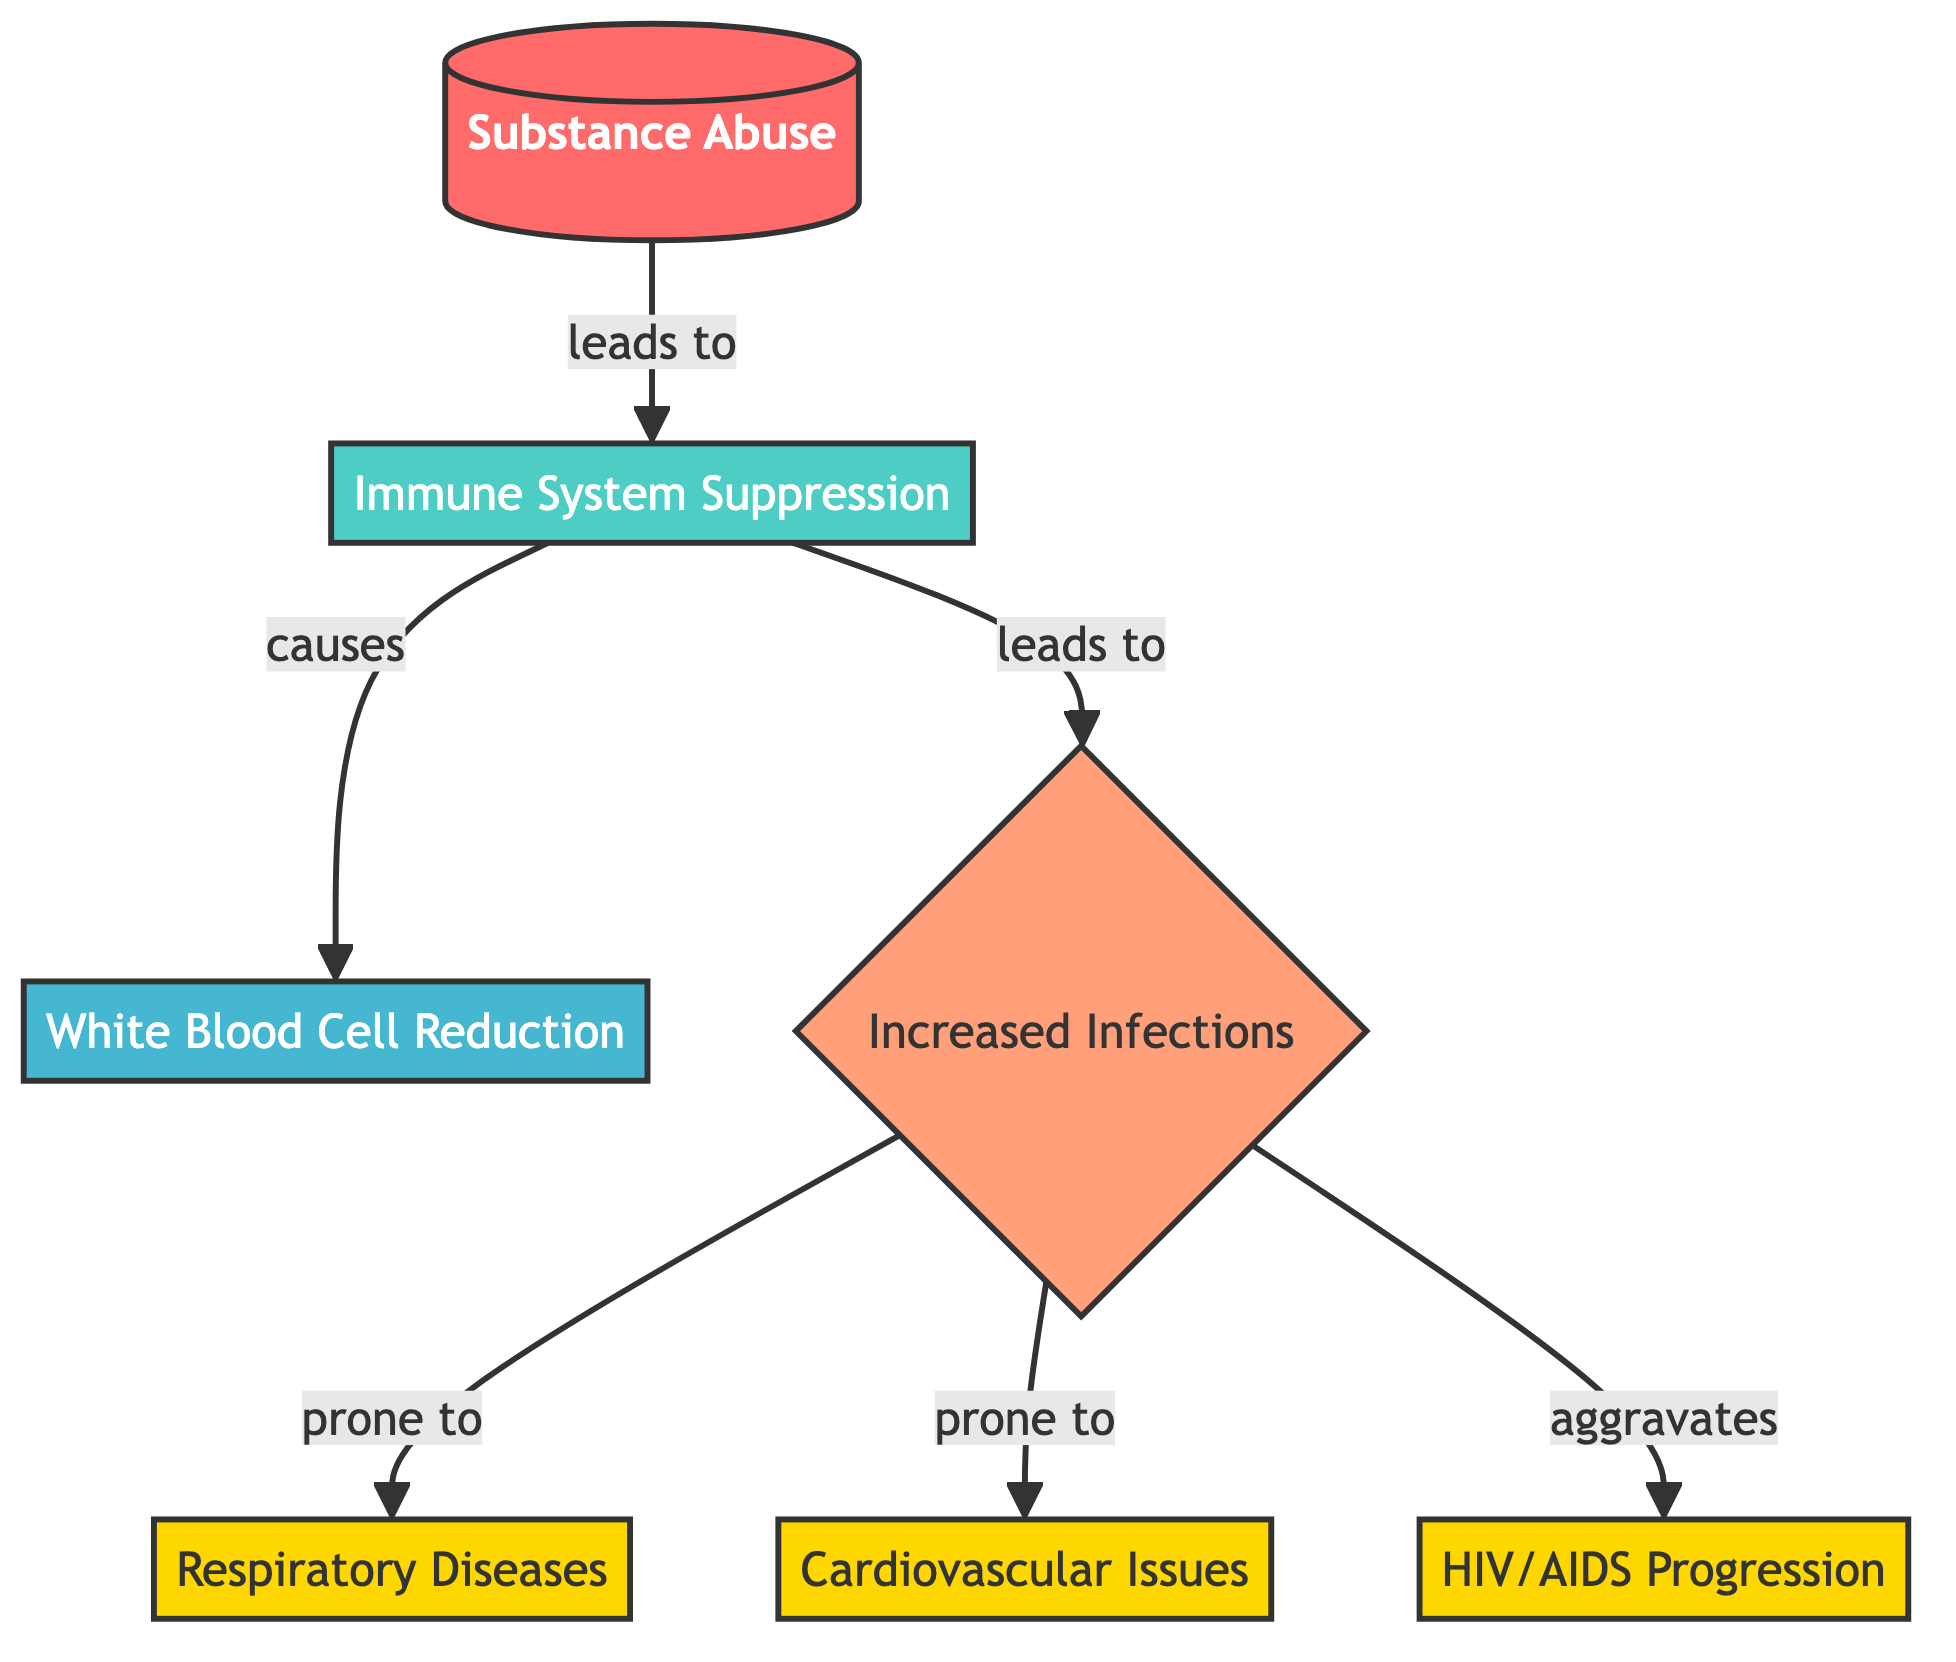What is the main cause illustrated in the diagram? The main cause illustrated is "Substance Abuse," which is the first node in the diagram and is depicted as leading to subsequent effects on the immune system.
Answer: Substance Abuse How many diseases are linked to increased infections? The diagram shows that there are three diseases linked to increased infections: Respiratory Diseases, Cardiovascular Issues, and HIV/AIDS Progression, counting them directly from the connections.
Answer: 3 What is the direct effect of immune system suppression? The direct effect of immune system suppression as per the diagram is "White Blood Cell Reduction," which is directly connected as a result of the immune system suppression node.
Answer: White Blood Cell Reduction Which condition aggravates HIV/AIDS? The diagram indicates that "Increased Infections" aggravates the progression of HIV/AIDS, as evidenced by the arrow pointing from Increased Infections to HIV/AIDS Progression.
Answer: Increased Infections What is the relationship between Substance Abuse and Immune System Suppression? The relationship is that Substance Abuse leads to Immune System Suppression, as indicated by the arrow pointing from Substance Abuse to Immune System Suppression in the diagram.
Answer: Leads to What forms the basis of vulnerability to diseases in the diagram? The basis of vulnerability to diseases is formed by "Increased Infections," which connects to the various diseases in the diagram, highlighting the link between immune suppression and disease susceptibility.
Answer: Increased Infections What are the three specific diseases listed in the diagram? The three specific diseases listed are "Respiratory Diseases," "Cardiovascular Issues," and "HIV/AIDS Progression," which are directly connected as outcomes of increased infections.
Answer: Respiratory Diseases, Cardiovascular Issues, HIV/AIDS Progression What happens to white blood cell count due to Immune System Suppression? The white blood cell count is reduced due to Immune System Suppression, which is directly depicted as the effect of the immune system suppression node in the diagram.
Answer: Reduced What does the diagram emphasize as a consequence of substance abuse? The diagram emphasizes "Immune System Suppression" as a significant consequence of substance abuse, showing the cascading effects that follow this initial impact.
Answer: Immune System Suppression How is cardiovascular health affected by substance abuse? Cardiovascular health is affected negatively as the diagram illustrates that increased infections, resulting from immune system suppression, lead to cardiovascular issues.
Answer: Cardiovascular Issues 